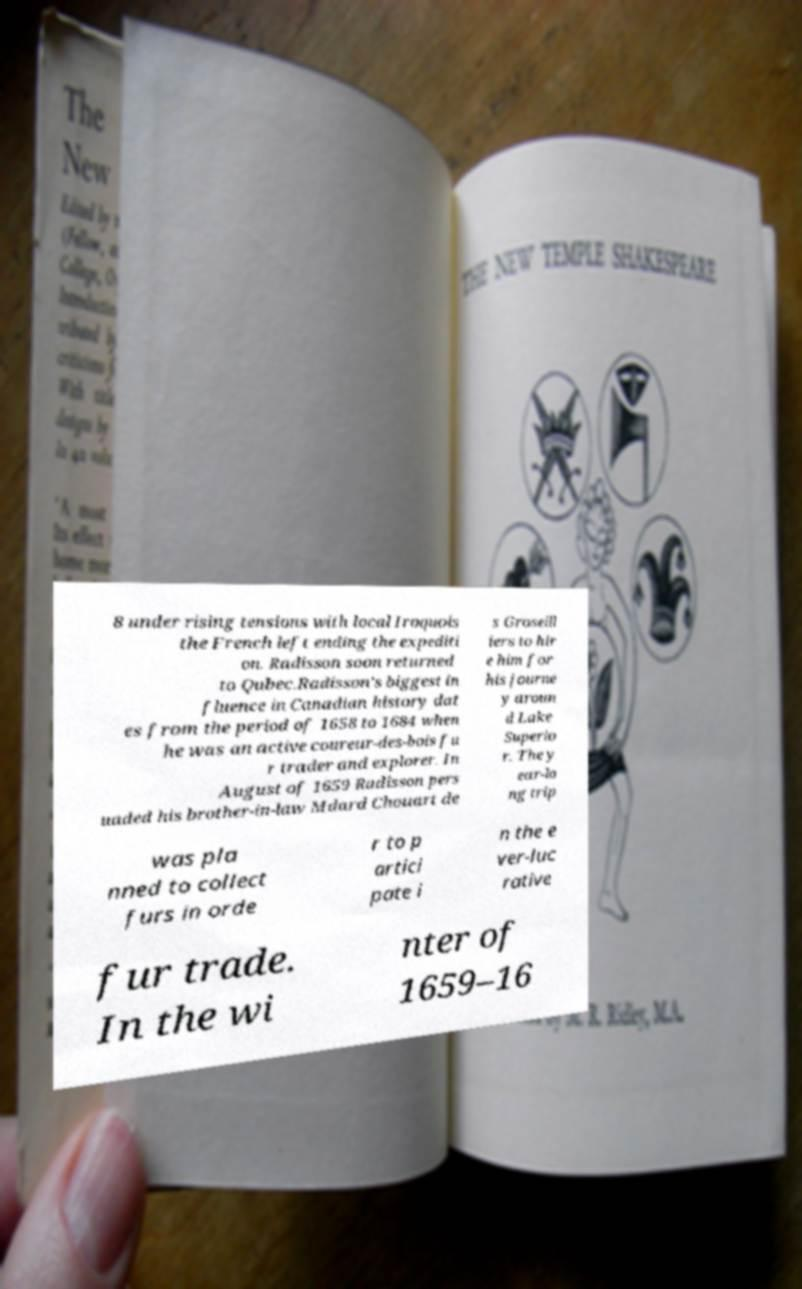Can you accurately transcribe the text from the provided image for me? 8 under rising tensions with local Iroquois the French left ending the expediti on. Radisson soon returned to Qubec.Radisson's biggest in fluence in Canadian history dat es from the period of 1658 to 1684 when he was an active coureur-des-bois fu r trader and explorer. In August of 1659 Radisson pers uaded his brother-in-law Mdard Chouart de s Groseill iers to hir e him for his journe y aroun d Lake Superio r. The y ear-lo ng trip was pla nned to collect furs in orde r to p artici pate i n the e ver-luc rative fur trade. In the wi nter of 1659–16 